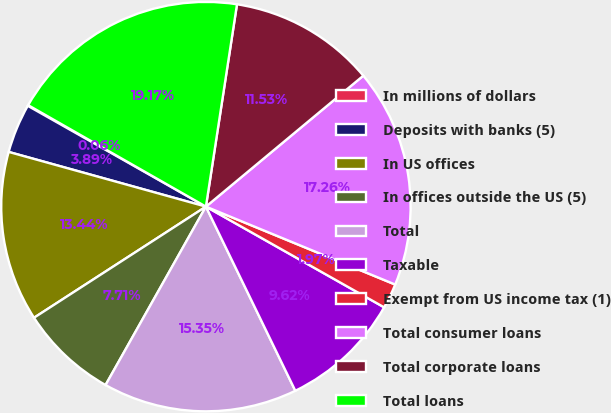Convert chart to OTSL. <chart><loc_0><loc_0><loc_500><loc_500><pie_chart><fcel>In millions of dollars<fcel>Deposits with banks (5)<fcel>In US offices<fcel>In offices outside the US (5)<fcel>Total<fcel>Taxable<fcel>Exempt from US income tax (1)<fcel>Total consumer loans<fcel>Total corporate loans<fcel>Total loans<nl><fcel>0.06%<fcel>3.89%<fcel>13.44%<fcel>7.71%<fcel>15.35%<fcel>9.62%<fcel>1.97%<fcel>17.26%<fcel>11.53%<fcel>19.17%<nl></chart> 